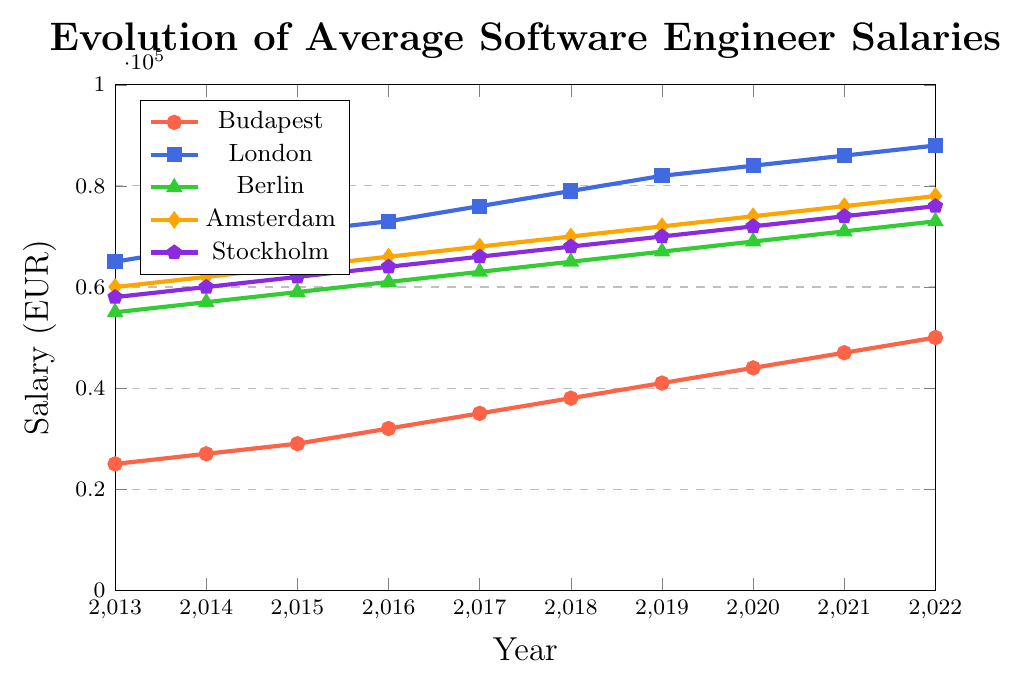what is the general trend of average salaries for software engineers in Budapest from 2013 to 2022? Over the years, the average salary for software engineers in Budapest shows a consistent upward trend. Starting from EUR 25,000 in 2013, it steadily increases each year, reaching EUR 50,000 in 2022.
Answer: Consistently upward Which city had the highest software engineer salaries in 2022? By looking at the end of each line in the figure for the year 2022, the line representing London (blue) is the highest, indicating it has the highest salaries.
Answer: London how much did the average software engineer salary in Berlin increase from 2013 to 2022? In 2013, the average salary in Berlin was EUR 55,000, and in 2022 it was EUR 73,000. Subtracting the 2013 value from the 2022 value gives an increase of EUR 73,000 - EUR 55,000 = EUR 18,000.
Answer: EUR 18,000 What is the average salary difference between Amsterdam and Stockholm in 2017? In 2017, the salary in Amsterdam was EUR 68,000 and in Stockholm, it was EUR 66,000. The difference is EUR 68,000 - EUR 66,000 = EUR 2,000.
Answer: EUR 2,000 Between which consecutive years did Budapest see the biggest increase in average salary? Checking the differences year by year for Budapest, the largest increase is between 2015 (EUR 29,000) and 2016 (EUR 32,000), which is EUR 32,000 - EUR 29,000 = EUR 3,000.
Answer: 2015-2016 By how much did the salary in London increase over the entire period from 2013 to 2022? In London, the salary increased from EUR 65,000 in 2013 to EUR 88,000 in 2022. The total increase is EUR 88,000 - EUR 65,000 = EUR 23,000.
Answer: EUR 23,000 Which cities had an average software engineer salary below EUR 50,000 in 2013? Looking at the year 2013, the lines for Budapest (EUR 25,000) are the only ones below EUR 50,000. None of the other cities (London, Berlin, Amsterdam, Stockholm) have salaries below EUR 50,000.
Answer: Budapest how do the salary trends of Amsterdam and Stockholm compare from 2013 to 2022? Both Amsterdam and Stockholm show a consistent increase in salaries from 2013 to 2022. However, Amsterdam started at a higher value (EUR 60,000 vs. EUR 58,000) and ended slightly higher (EUR 78,000 vs. EUR 76,000). The trends are almost parallel, indicating similar growth rates.
Answer: Similar growth rates, Amsterdam started and ended higher What are the colors representing each city in the plot? The colors are as follows: Budapest - red, London - blue, Berlin - green, Amsterdam - orange, Stockholm - purple.
Answer: Budapest - red, London - blue, Berlin - green, Amsterdam - orange, Stockholm - purple Comparing 2020 and 2022, which city had the smallest salary growth? Subtracting the 2020 from 2022 salaries for each city: Budapest (EUR 50,000 - EUR 44,000 = EUR 6,000), London (EUR 88,000 - EUR 84,000 = EUR 4,000), Berlin (EUR 73,000 - EUR 69,000 = EUR 4,000), Amsterdam (EUR 78,000 - EUR 74,000 = EUR 4,000), Stockholm (EUR 76,000 - EUR 72,000 = EUR 4,000). All cities except Budapest had the same growth of EUR 4,000 in this period.
Answer: London, Berlin, Amsterdam, Stockholm - EUR 4,000 each 